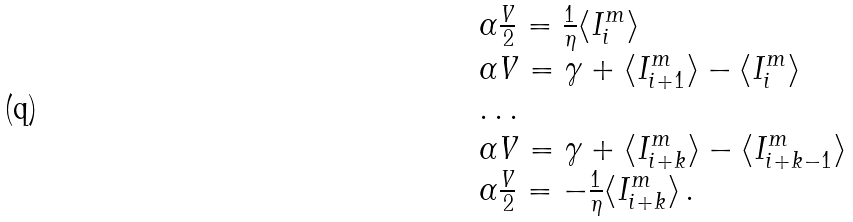<formula> <loc_0><loc_0><loc_500><loc_500>\begin{array} { l c r } \alpha \frac { V } { 2 } = \frac { 1 } { \eta } \langle I ^ { m } _ { i } \rangle \\ \alpha V = \gamma + \langle I ^ { m } _ { i + 1 } \rangle - \langle I ^ { m } _ { i } \rangle \\ \dots \\ \alpha V = \gamma + \langle I ^ { m } _ { i + k } \rangle - \langle I ^ { m } _ { i + k - 1 } \rangle \\ \alpha \frac { V } { 2 } = - \frac { 1 } { \eta } \langle I ^ { m } _ { i + k } \rangle \, . \end{array}</formula> 